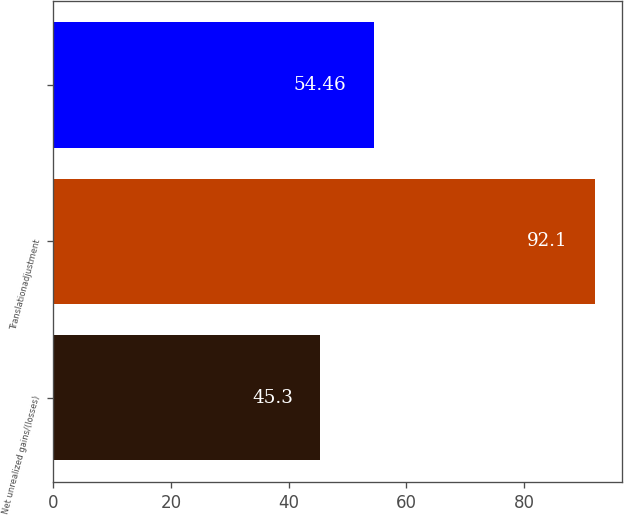<chart> <loc_0><loc_0><loc_500><loc_500><bar_chart><fcel>Net unrealized gains/(losses)<fcel>Translationadjustment<fcel>Unnamed: 2<nl><fcel>45.3<fcel>92.1<fcel>54.46<nl></chart> 